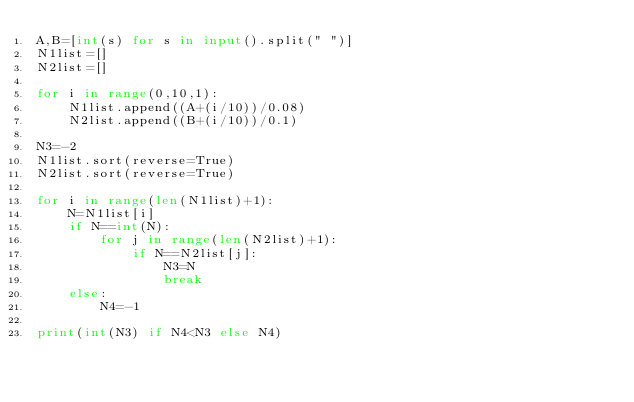Convert code to text. <code><loc_0><loc_0><loc_500><loc_500><_Python_>A,B=[int(s) for s in input().split(" ")]
N1list=[]
N2list=[]

for i in range(0,10,1):
    N1list.append((A+(i/10))/0.08)   
    N2list.append((B+(i/10))/0.1)

N3=-2
N1list.sort(reverse=True)
N2list.sort(reverse=True)

for i in range(len(N1list)+1):
    N=N1list[i]
    if N==int(N):
        for j in range(len(N2list)+1):
            if N==N2list[j]:
                N3=N
                break
    else:
        N4=-1

print(int(N3) if N4<N3 else N4)</code> 